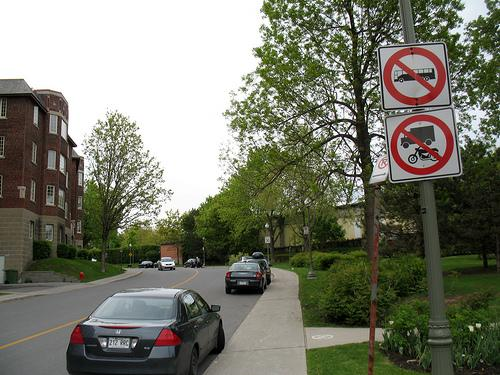How many signs have a diagonal line through them? Please explain your reasoning. two. Both signs have them. 